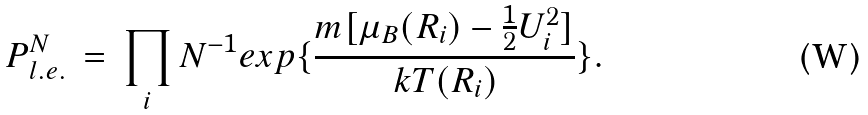Convert formula to latex. <formula><loc_0><loc_0><loc_500><loc_500>P ^ { N } _ { l . e . } \, = \, \prod _ { i } N ^ { - 1 } e x p \{ \frac { m [ \mu _ { B } ( { R } _ { i } ) - \frac { 1 } { 2 } { U } _ { i } ^ { 2 } ] } { k T ( { R } _ { i } ) } \} .</formula> 